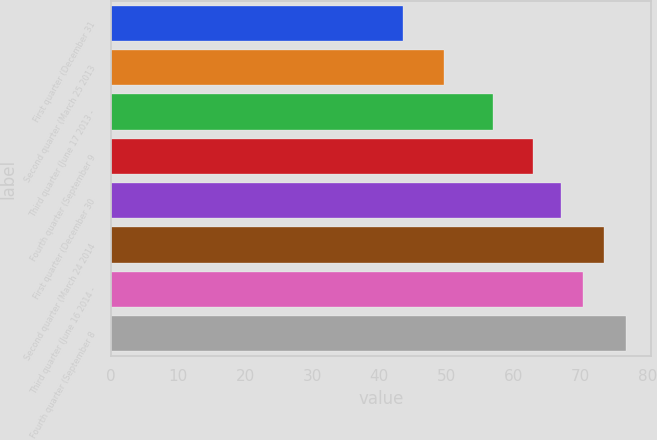<chart> <loc_0><loc_0><loc_500><loc_500><bar_chart><fcel>First quarter (December 31<fcel>Second quarter (March 25 2013<fcel>Third quarter (June 17 2013 -<fcel>Fourth quarter (September 9<fcel>First quarter (December 30<fcel>Second quarter (March 24 2014<fcel>Third quarter (June 16 2014 -<fcel>Fourth quarter (September 8<nl><fcel>43.55<fcel>49.65<fcel>57.01<fcel>63.04<fcel>67.17<fcel>73.57<fcel>70.37<fcel>76.77<nl></chart> 